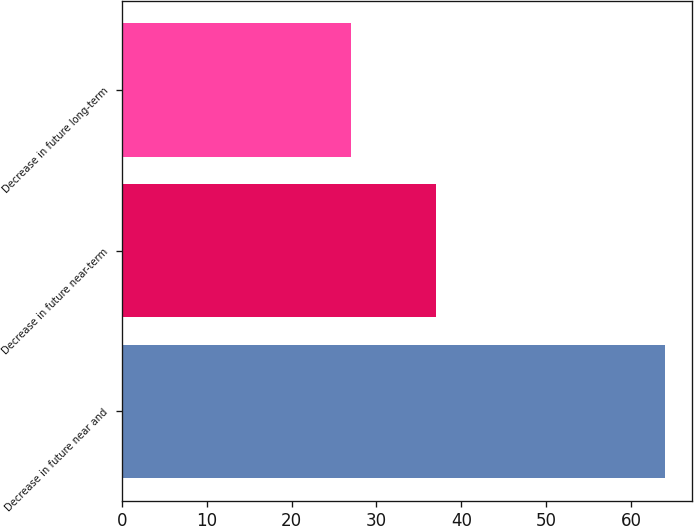Convert chart. <chart><loc_0><loc_0><loc_500><loc_500><bar_chart><fcel>Decrease in future near and<fcel>Decrease in future near-term<fcel>Decrease in future long-term<nl><fcel>64<fcel>37<fcel>27<nl></chart> 